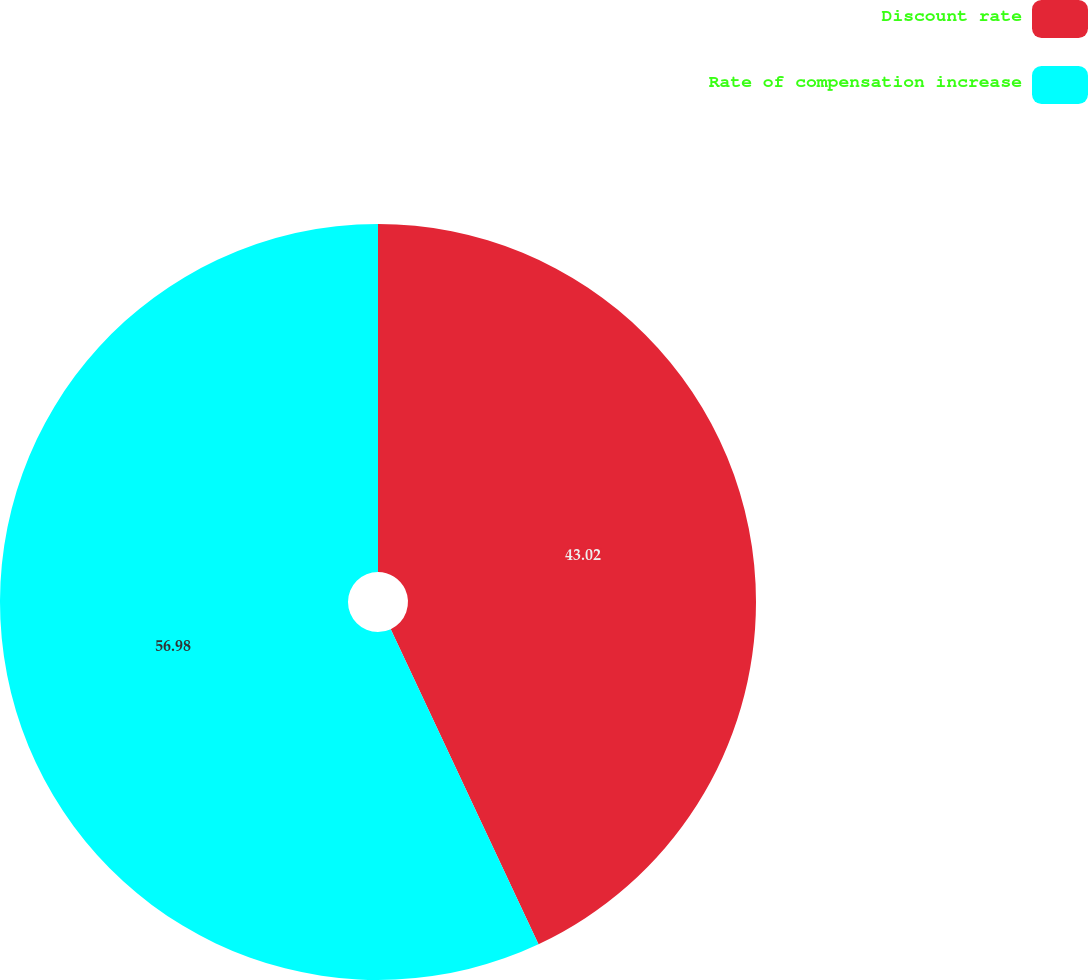<chart> <loc_0><loc_0><loc_500><loc_500><pie_chart><fcel>Discount rate<fcel>Rate of compensation increase<nl><fcel>43.02%<fcel>56.98%<nl></chart> 